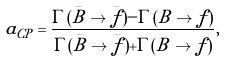Convert formula to latex. <formula><loc_0><loc_0><loc_500><loc_500>a _ { C P } = \frac { \Gamma ( \bar { B } \to \bar { f } ) - \Gamma ( B \to f ) } { \Gamma ( \bar { B } \to \bar { f } ) + \Gamma ( B \to f ) } ,</formula> 